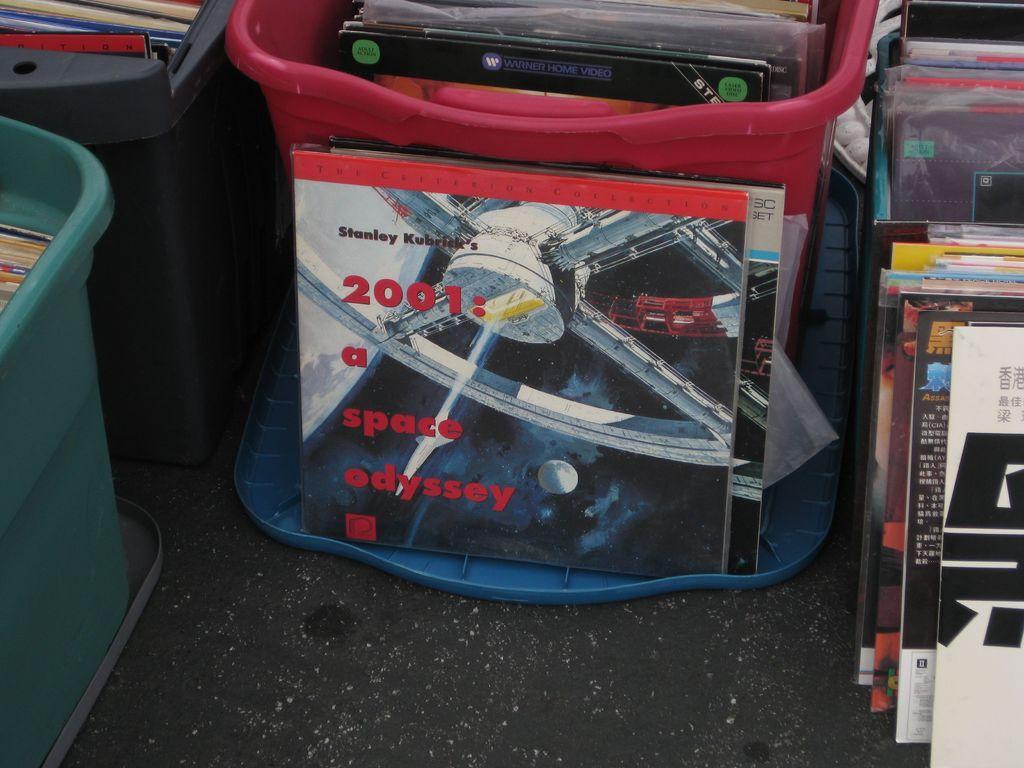How would you summarize this image in a sentence or two? In this picture we can see some boxes, there are some books present on these boxes, we can see some text on this book. 